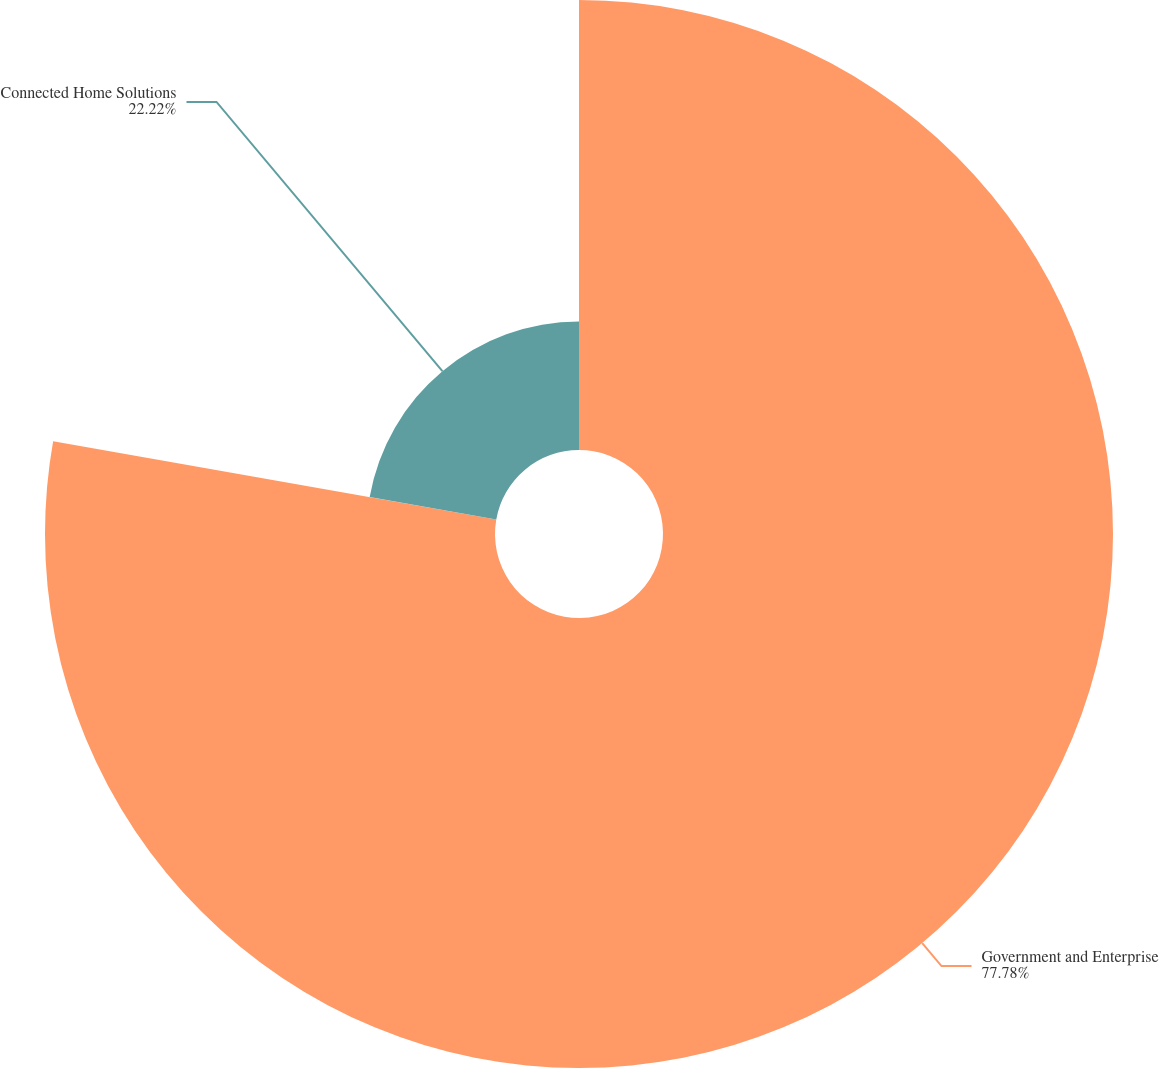<chart> <loc_0><loc_0><loc_500><loc_500><pie_chart><fcel>Government and Enterprise<fcel>Connected Home Solutions<nl><fcel>77.78%<fcel>22.22%<nl></chart> 